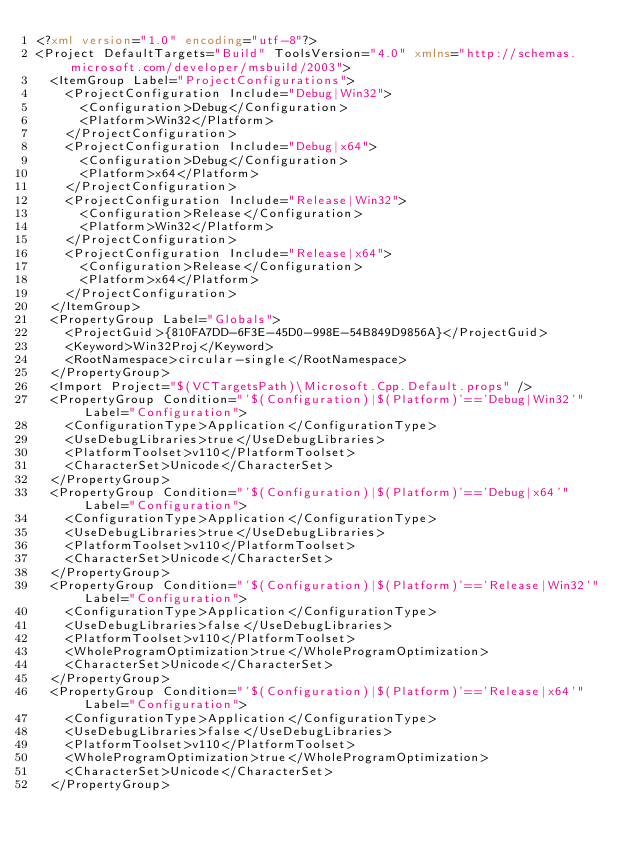<code> <loc_0><loc_0><loc_500><loc_500><_XML_><?xml version="1.0" encoding="utf-8"?>
<Project DefaultTargets="Build" ToolsVersion="4.0" xmlns="http://schemas.microsoft.com/developer/msbuild/2003">
  <ItemGroup Label="ProjectConfigurations">
    <ProjectConfiguration Include="Debug|Win32">
      <Configuration>Debug</Configuration>
      <Platform>Win32</Platform>
    </ProjectConfiguration>
    <ProjectConfiguration Include="Debug|x64">
      <Configuration>Debug</Configuration>
      <Platform>x64</Platform>
    </ProjectConfiguration>
    <ProjectConfiguration Include="Release|Win32">
      <Configuration>Release</Configuration>
      <Platform>Win32</Platform>
    </ProjectConfiguration>
    <ProjectConfiguration Include="Release|x64">
      <Configuration>Release</Configuration>
      <Platform>x64</Platform>
    </ProjectConfiguration>
  </ItemGroup>
  <PropertyGroup Label="Globals">
    <ProjectGuid>{810FA7DD-6F3E-45D0-998E-54B849D9856A}</ProjectGuid>
    <Keyword>Win32Proj</Keyword>
    <RootNamespace>circular-single</RootNamespace>
  </PropertyGroup>
  <Import Project="$(VCTargetsPath)\Microsoft.Cpp.Default.props" />
  <PropertyGroup Condition="'$(Configuration)|$(Platform)'=='Debug|Win32'" Label="Configuration">
    <ConfigurationType>Application</ConfigurationType>
    <UseDebugLibraries>true</UseDebugLibraries>
    <PlatformToolset>v110</PlatformToolset>
    <CharacterSet>Unicode</CharacterSet>
  </PropertyGroup>
  <PropertyGroup Condition="'$(Configuration)|$(Platform)'=='Debug|x64'" Label="Configuration">
    <ConfigurationType>Application</ConfigurationType>
    <UseDebugLibraries>true</UseDebugLibraries>
    <PlatformToolset>v110</PlatformToolset>
    <CharacterSet>Unicode</CharacterSet>
  </PropertyGroup>
  <PropertyGroup Condition="'$(Configuration)|$(Platform)'=='Release|Win32'" Label="Configuration">
    <ConfigurationType>Application</ConfigurationType>
    <UseDebugLibraries>false</UseDebugLibraries>
    <PlatformToolset>v110</PlatformToolset>
    <WholeProgramOptimization>true</WholeProgramOptimization>
    <CharacterSet>Unicode</CharacterSet>
  </PropertyGroup>
  <PropertyGroup Condition="'$(Configuration)|$(Platform)'=='Release|x64'" Label="Configuration">
    <ConfigurationType>Application</ConfigurationType>
    <UseDebugLibraries>false</UseDebugLibraries>
    <PlatformToolset>v110</PlatformToolset>
    <WholeProgramOptimization>true</WholeProgramOptimization>
    <CharacterSet>Unicode</CharacterSet>
  </PropertyGroup></code> 